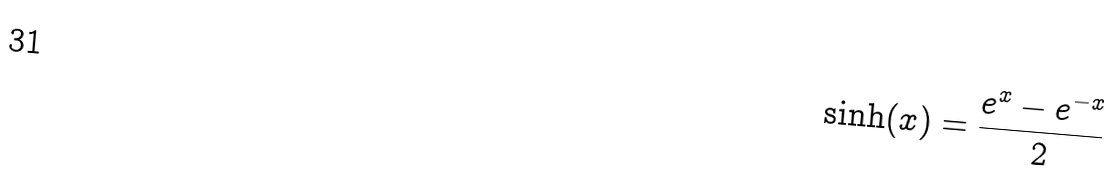<formula> <loc_0><loc_0><loc_500><loc_500>\sinh ( x ) = \frac { e ^ { x } - e ^ { - x } } { 2 }</formula> 